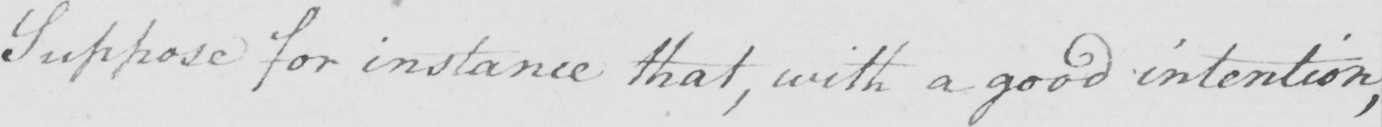What does this handwritten line say? Suppose for instance that , with a good intention , 